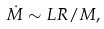Convert formula to latex. <formula><loc_0><loc_0><loc_500><loc_500>\dot { M } \sim L R / M ,</formula> 